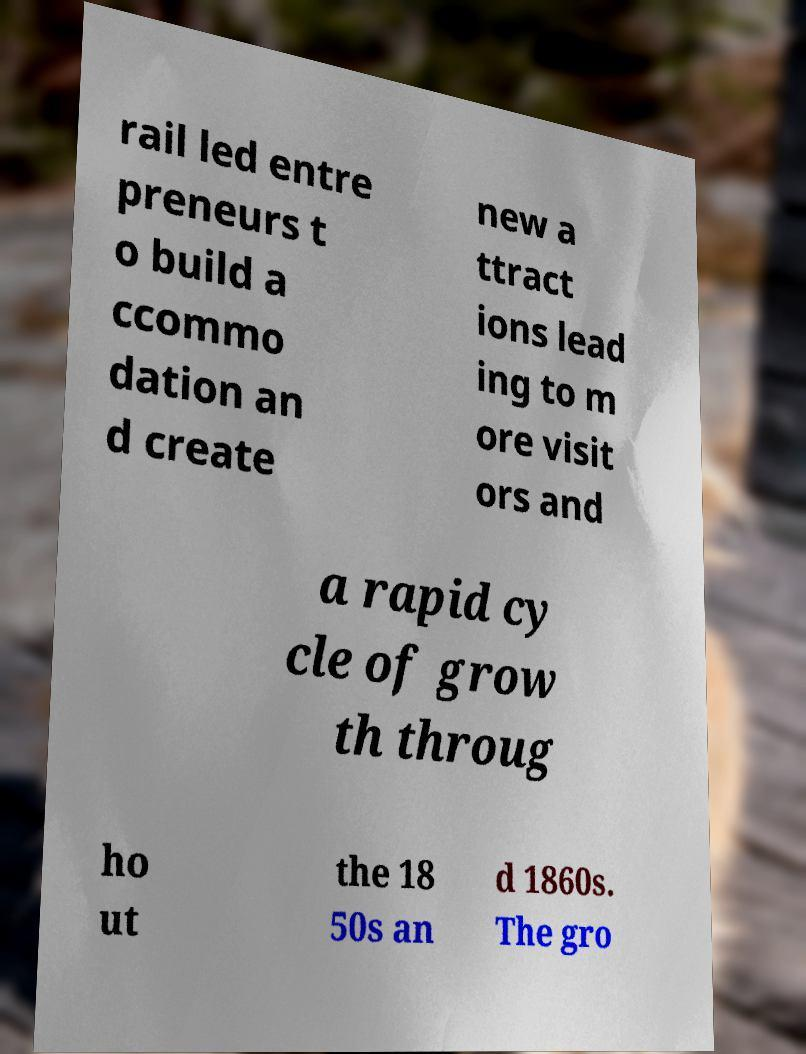For documentation purposes, I need the text within this image transcribed. Could you provide that? rail led entre preneurs t o build a ccommo dation an d create new a ttract ions lead ing to m ore visit ors and a rapid cy cle of grow th throug ho ut the 18 50s an d 1860s. The gro 